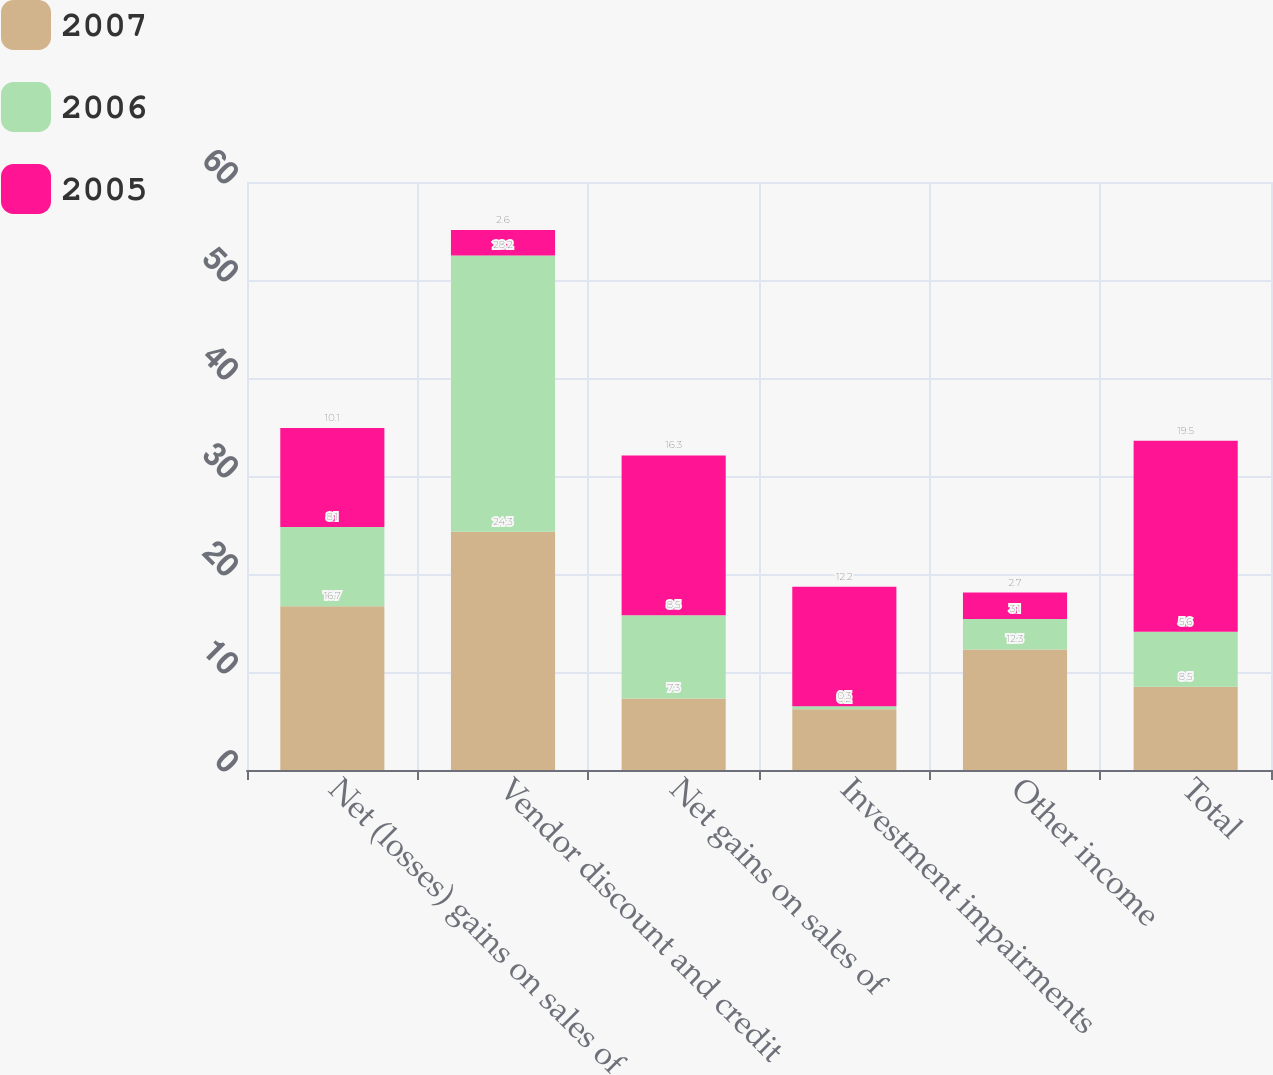Convert chart. <chart><loc_0><loc_0><loc_500><loc_500><stacked_bar_chart><ecel><fcel>Net (losses) gains on sales of<fcel>Vendor discount and credit<fcel>Net gains on sales of<fcel>Investment impairments<fcel>Other income<fcel>Total<nl><fcel>2007<fcel>16.7<fcel>24.3<fcel>7.3<fcel>6.2<fcel>12.3<fcel>8.5<nl><fcel>2006<fcel>8.1<fcel>28.2<fcel>8.5<fcel>0.3<fcel>3.1<fcel>5.6<nl><fcel>2005<fcel>10.1<fcel>2.6<fcel>16.3<fcel>12.2<fcel>2.7<fcel>19.5<nl></chart> 